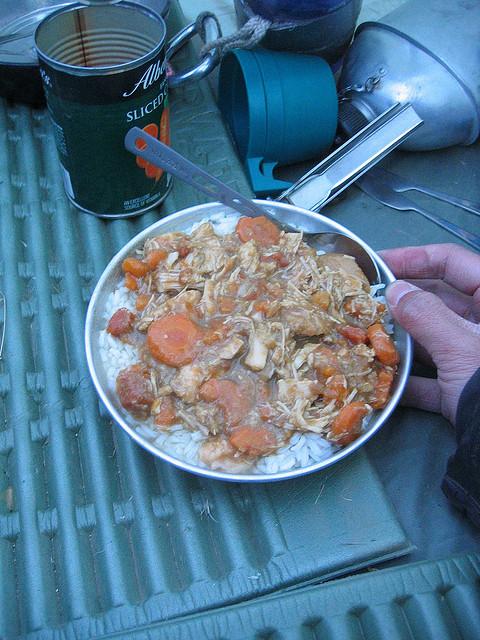What utensil is in the bowl?
Keep it brief. Spoon. What metallic covering is wrapped around an object in the top right corner?
Keep it brief. Tin. Is this a gourmet meal?
Quick response, please. No. What utensil is in the pan?
Short answer required. Spoon. Where did the food come from?
Keep it brief. Can. Which dish holds an upside down spoon?
Answer briefly. Bowl. What is the purpose of the metal squares on the plate?
Short answer required. Dividing. 